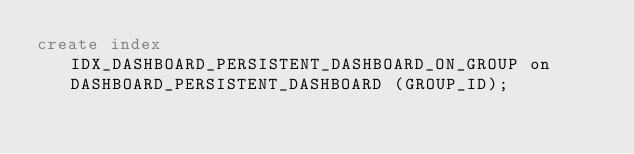<code> <loc_0><loc_0><loc_500><loc_500><_SQL_>create index IDX_DASHBOARD_PERSISTENT_DASHBOARD_ON_GROUP on DASHBOARD_PERSISTENT_DASHBOARD (GROUP_ID);
</code> 